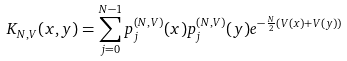Convert formula to latex. <formula><loc_0><loc_0><loc_500><loc_500>K _ { N , V } ( x , y ) = \sum _ { j = 0 } ^ { N - 1 } p _ { j } ^ { ( N , V ) } ( x ) p _ { j } ^ { ( N , V ) } ( y ) e ^ { - \frac { N } { 2 } ( V ( x ) + V ( y ) ) }</formula> 